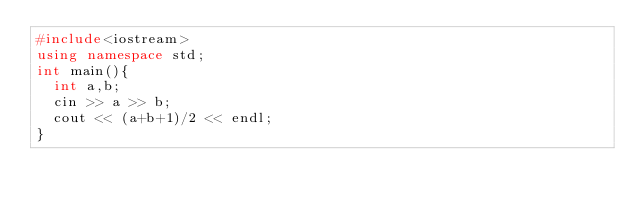<code> <loc_0><loc_0><loc_500><loc_500><_C++_>#include<iostream>
using namespace std;
int main(){
  int a,b;
  cin >> a >> b;
  cout << (a+b+1)/2 << endl;
}</code> 